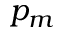Convert formula to latex. <formula><loc_0><loc_0><loc_500><loc_500>p _ { m }</formula> 